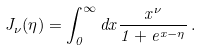<formula> <loc_0><loc_0><loc_500><loc_500>J _ { \nu } ( \eta ) = \int _ { 0 } ^ { \infty } d x \frac { x ^ { \nu } } { 1 + e ^ { x - \eta } } \, .</formula> 